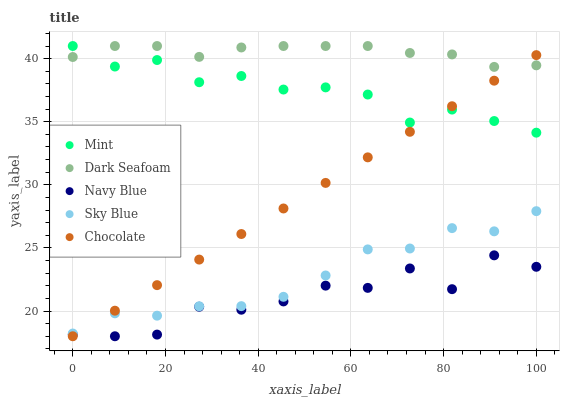Does Navy Blue have the minimum area under the curve?
Answer yes or no. Yes. Does Dark Seafoam have the maximum area under the curve?
Answer yes or no. Yes. Does Chocolate have the minimum area under the curve?
Answer yes or no. No. Does Chocolate have the maximum area under the curve?
Answer yes or no. No. Is Chocolate the smoothest?
Answer yes or no. Yes. Is Navy Blue the roughest?
Answer yes or no. Yes. Is Dark Seafoam the smoothest?
Answer yes or no. No. Is Dark Seafoam the roughest?
Answer yes or no. No. Does Navy Blue have the lowest value?
Answer yes or no. Yes. Does Dark Seafoam have the lowest value?
Answer yes or no. No. Does Mint have the highest value?
Answer yes or no. Yes. Does Chocolate have the highest value?
Answer yes or no. No. Is Navy Blue less than Dark Seafoam?
Answer yes or no. Yes. Is Dark Seafoam greater than Navy Blue?
Answer yes or no. Yes. Does Dark Seafoam intersect Chocolate?
Answer yes or no. Yes. Is Dark Seafoam less than Chocolate?
Answer yes or no. No. Is Dark Seafoam greater than Chocolate?
Answer yes or no. No. Does Navy Blue intersect Dark Seafoam?
Answer yes or no. No. 